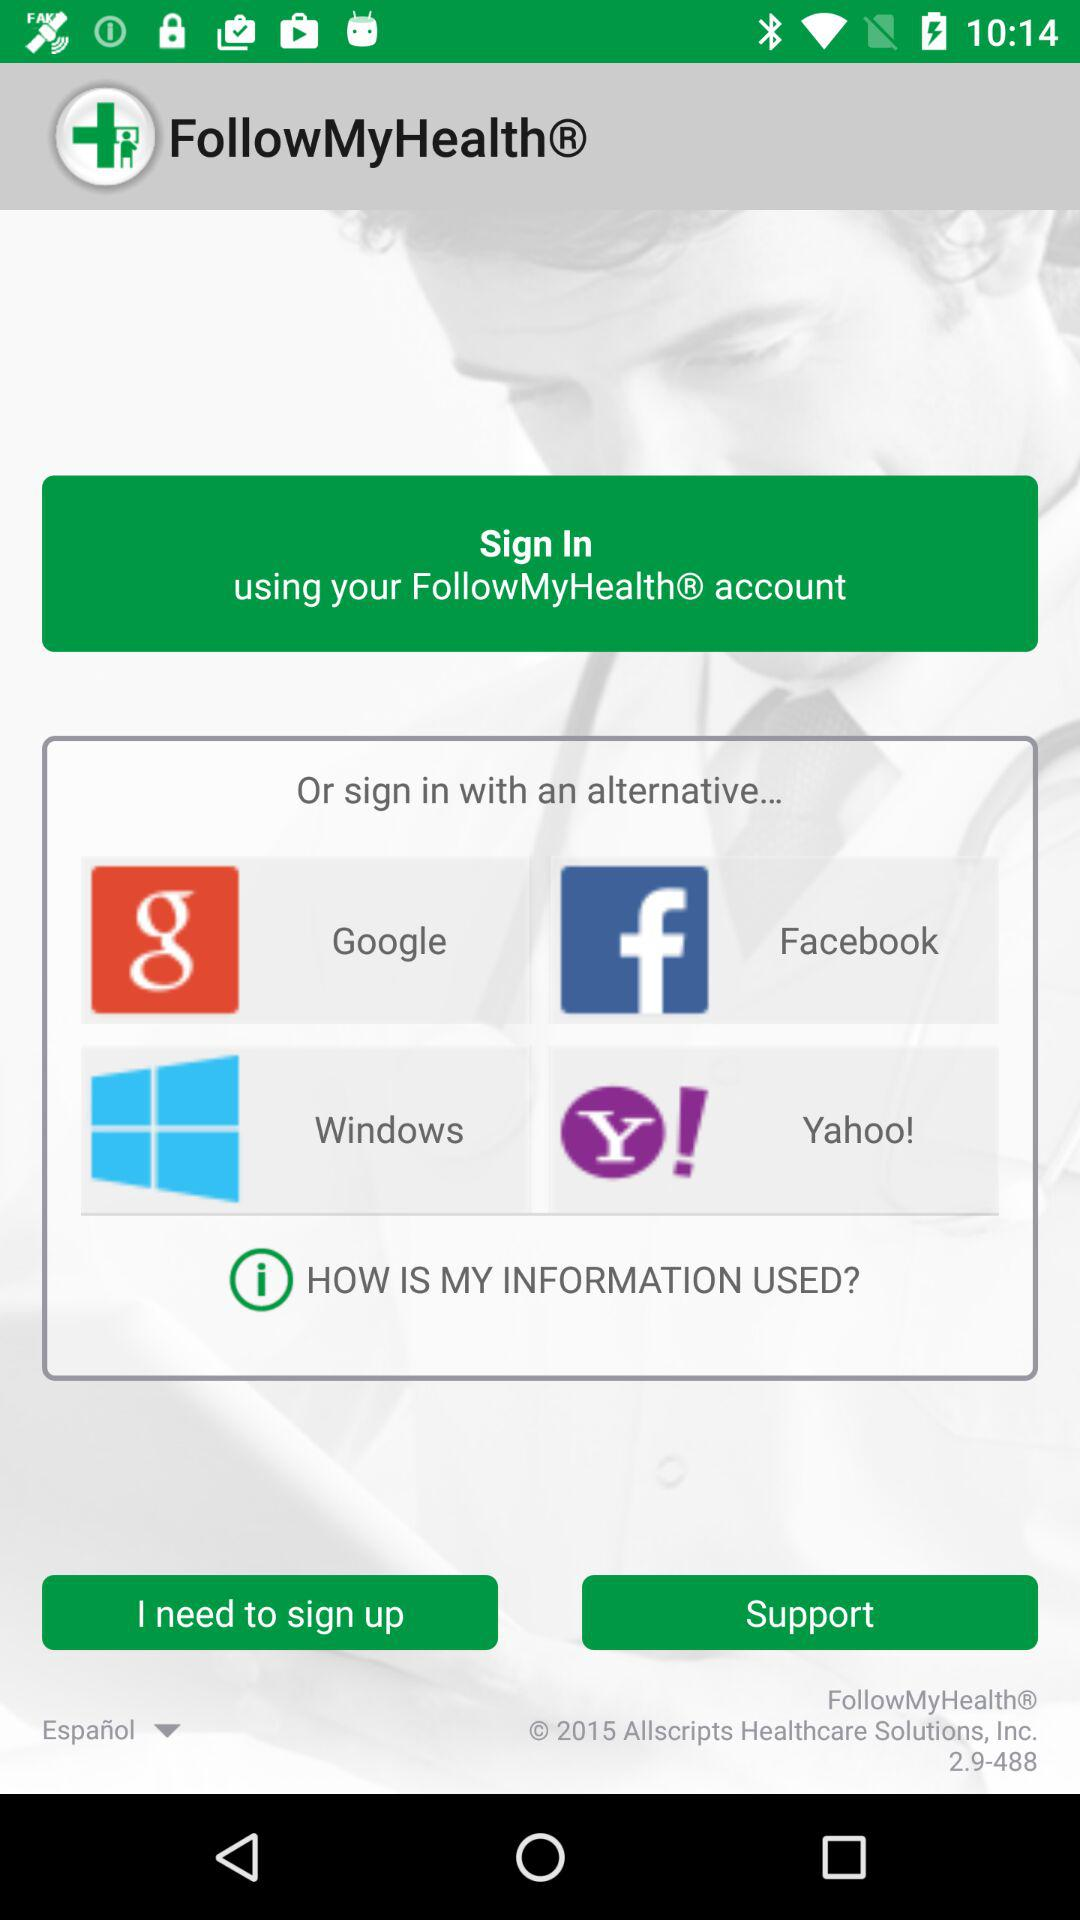Which applications can be used to sign in? The applications that can be used to sign in are "Google", "Windows", "Yahoo!" and "Facebook". 